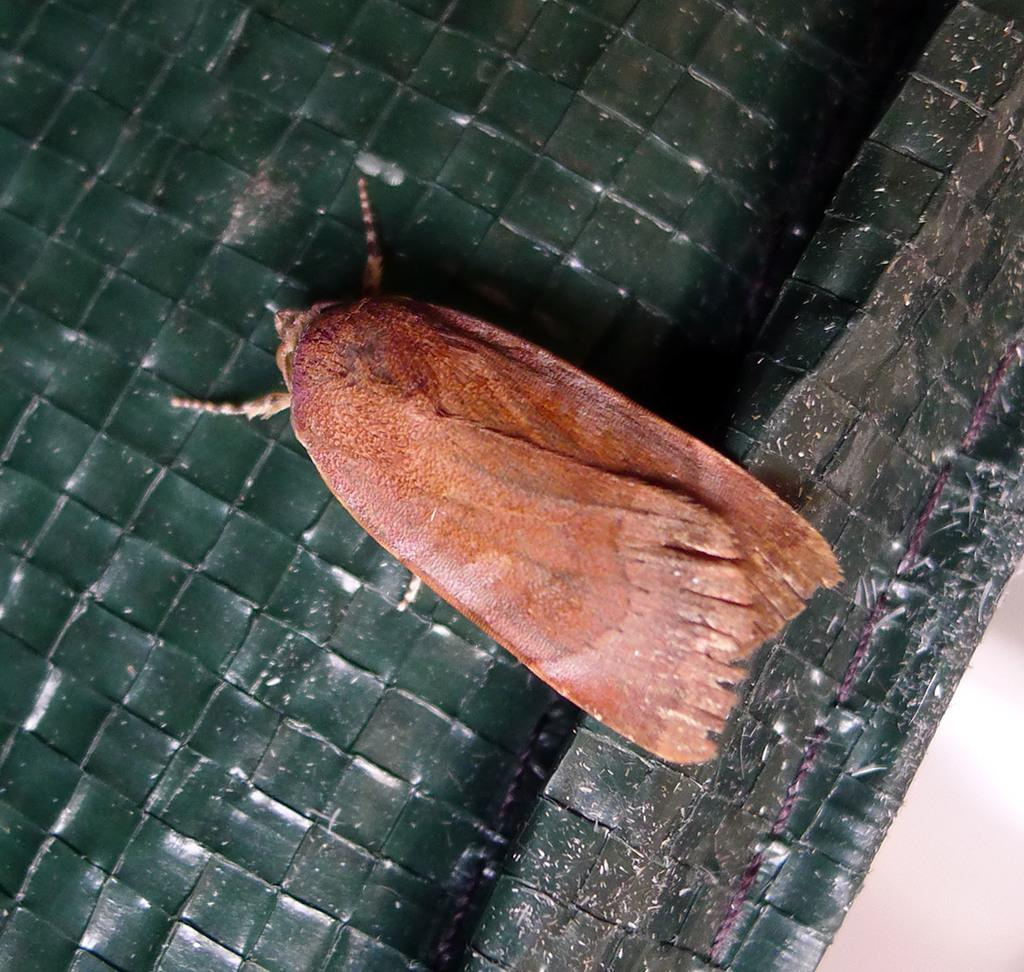What type of creature is present in the image? There is an insect in the image. What colors can be seen on the insect? The insect has gold, brown, and pink coloration. What is the background or surface on which the insect is located? The insect is on a green-colored surface. How many quarters are stacked on top of each other in the image? There are no quarters present in the image. What type of activity are the brothers engaged in within the image? There is no mention of brothers or any specific activity in the image. 